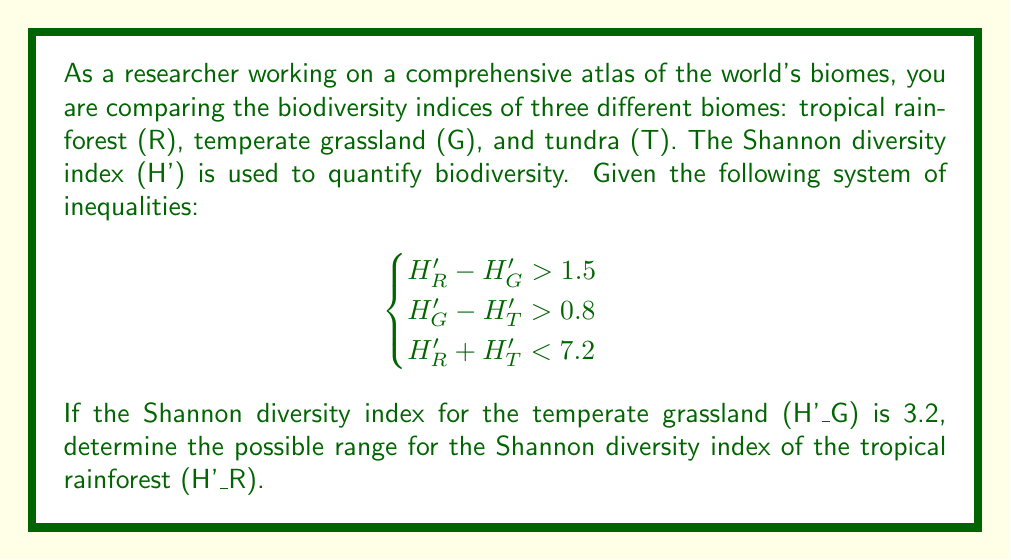Can you solve this math problem? Let's approach this step-by-step:

1) From the given information, we know that H'_G = 3.2.

2) Using the first inequality: H'_R - H'_G > 1.5
   Substituting H'_G = 3.2:
   H'_R - 3.2 > 1.5
   H'_R > 4.7

3) Using the second inequality: H'_G - H'_T > 0.8
   Substituting H'_G = 3.2:
   3.2 - H'_T > 0.8
   -H'_T > -2.4
   H'_T < 2.4

4) Now, let's use the third inequality: H'_R + H'_T < 7.2
   We can substitute the upper bound for H'_T (2.4) to find the upper bound for H'_R:
   H'_R + 2.4 < 7.2
   H'_R < 4.8

5) Combining the results from steps 2 and 4, we get:
   4.7 < H'_R < 4.8

Therefore, the Shannon diversity index for the tropical rainforest (H'_R) must be between 4.7 and 4.8.
Answer: The possible range for the Shannon diversity index of the tropical rainforest (H'_R) is:

$4.7 < H'_R < 4.8$ 